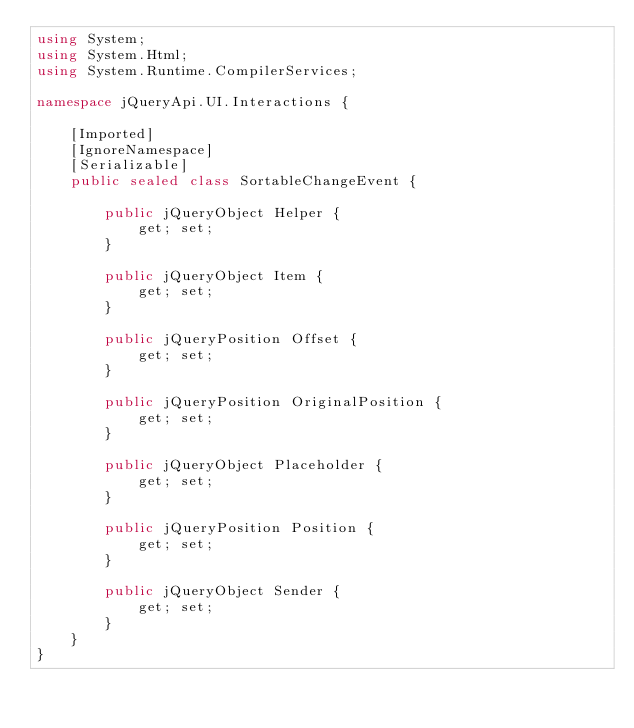<code> <loc_0><loc_0><loc_500><loc_500><_C#_>using System;
using System.Html;
using System.Runtime.CompilerServices;

namespace jQueryApi.UI.Interactions {

    [Imported]
    [IgnoreNamespace]
    [Serializable]
    public sealed class SortableChangeEvent {

        public jQueryObject Helper {
            get; set;
        }

        public jQueryObject Item {
            get; set;
        }

        public jQueryPosition Offset {
            get; set;
        }

        public jQueryPosition OriginalPosition {
            get; set;
        }

        public jQueryObject Placeholder {
            get; set;
        }

        public jQueryPosition Position {
            get; set;
        }

        public jQueryObject Sender {
            get; set;
        }
    }
}
</code> 